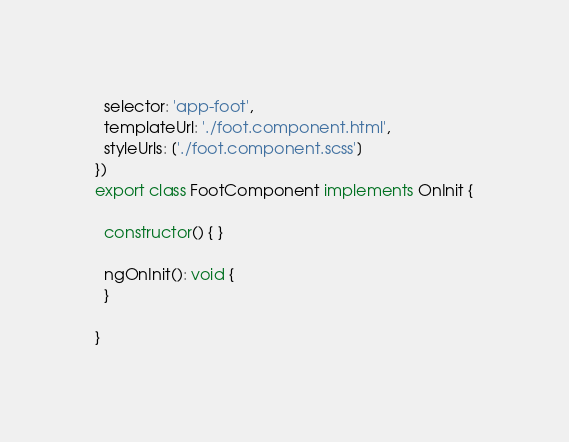<code> <loc_0><loc_0><loc_500><loc_500><_TypeScript_>  selector: 'app-foot',
  templateUrl: './foot.component.html',
  styleUrls: ['./foot.component.scss']
})
export class FootComponent implements OnInit {

  constructor() { }

  ngOnInit(): void {
  }

}
</code> 